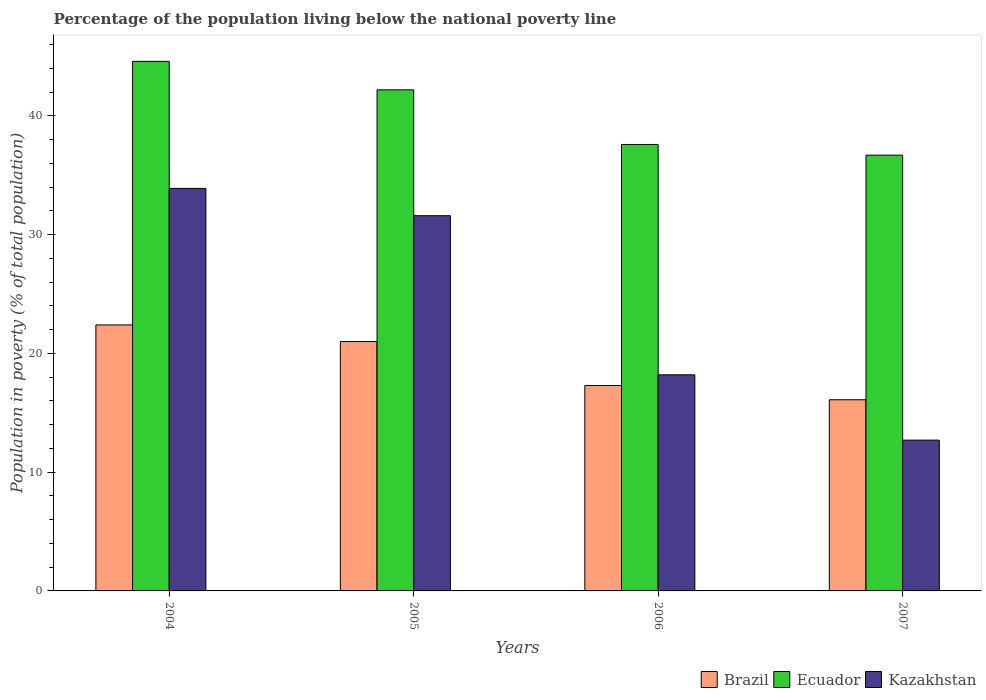How many bars are there on the 1st tick from the left?
Your response must be concise. 3. What is the label of the 4th group of bars from the left?
Give a very brief answer. 2007. What is the percentage of the population living below the national poverty line in Ecuador in 2007?
Ensure brevity in your answer.  36.7. Across all years, what is the maximum percentage of the population living below the national poverty line in Brazil?
Offer a terse response. 22.4. In which year was the percentage of the population living below the national poverty line in Brazil maximum?
Make the answer very short. 2004. What is the total percentage of the population living below the national poverty line in Kazakhstan in the graph?
Provide a succinct answer. 96.4. What is the difference between the percentage of the population living below the national poverty line in Kazakhstan in 2005 and that in 2007?
Your answer should be very brief. 18.9. What is the difference between the percentage of the population living below the national poverty line in Ecuador in 2007 and the percentage of the population living below the national poverty line in Kazakhstan in 2005?
Keep it short and to the point. 5.1. What is the average percentage of the population living below the national poverty line in Kazakhstan per year?
Offer a very short reply. 24.1. In the year 2007, what is the difference between the percentage of the population living below the national poverty line in Ecuador and percentage of the population living below the national poverty line in Kazakhstan?
Offer a terse response. 24. What is the ratio of the percentage of the population living below the national poverty line in Kazakhstan in 2004 to that in 2006?
Provide a short and direct response. 1.86. Is the difference between the percentage of the population living below the national poverty line in Ecuador in 2004 and 2006 greater than the difference between the percentage of the population living below the national poverty line in Kazakhstan in 2004 and 2006?
Make the answer very short. No. What is the difference between the highest and the second highest percentage of the population living below the national poverty line in Kazakhstan?
Your response must be concise. 2.3. What is the difference between the highest and the lowest percentage of the population living below the national poverty line in Kazakhstan?
Your answer should be compact. 21.2. In how many years, is the percentage of the population living below the national poverty line in Kazakhstan greater than the average percentage of the population living below the national poverty line in Kazakhstan taken over all years?
Provide a succinct answer. 2. What does the 1st bar from the left in 2007 represents?
Offer a terse response. Brazil. What does the 1st bar from the right in 2004 represents?
Your response must be concise. Kazakhstan. How many years are there in the graph?
Your answer should be compact. 4. What is the difference between two consecutive major ticks on the Y-axis?
Provide a succinct answer. 10. Are the values on the major ticks of Y-axis written in scientific E-notation?
Your answer should be compact. No. Does the graph contain any zero values?
Offer a terse response. No. What is the title of the graph?
Your answer should be compact. Percentage of the population living below the national poverty line. What is the label or title of the X-axis?
Offer a very short reply. Years. What is the label or title of the Y-axis?
Give a very brief answer. Population in poverty (% of total population). What is the Population in poverty (% of total population) of Brazil in 2004?
Provide a short and direct response. 22.4. What is the Population in poverty (% of total population) in Ecuador in 2004?
Give a very brief answer. 44.6. What is the Population in poverty (% of total population) in Kazakhstan in 2004?
Your answer should be very brief. 33.9. What is the Population in poverty (% of total population) in Brazil in 2005?
Make the answer very short. 21. What is the Population in poverty (% of total population) of Ecuador in 2005?
Your answer should be compact. 42.2. What is the Population in poverty (% of total population) of Kazakhstan in 2005?
Provide a short and direct response. 31.6. What is the Population in poverty (% of total population) in Ecuador in 2006?
Offer a terse response. 37.6. What is the Population in poverty (% of total population) in Ecuador in 2007?
Offer a very short reply. 36.7. Across all years, what is the maximum Population in poverty (% of total population) in Brazil?
Offer a terse response. 22.4. Across all years, what is the maximum Population in poverty (% of total population) of Ecuador?
Provide a succinct answer. 44.6. Across all years, what is the maximum Population in poverty (% of total population) in Kazakhstan?
Ensure brevity in your answer.  33.9. Across all years, what is the minimum Population in poverty (% of total population) of Ecuador?
Offer a very short reply. 36.7. Across all years, what is the minimum Population in poverty (% of total population) of Kazakhstan?
Your response must be concise. 12.7. What is the total Population in poverty (% of total population) in Brazil in the graph?
Make the answer very short. 76.8. What is the total Population in poverty (% of total population) in Ecuador in the graph?
Your answer should be compact. 161.1. What is the total Population in poverty (% of total population) of Kazakhstan in the graph?
Ensure brevity in your answer.  96.4. What is the difference between the Population in poverty (% of total population) of Kazakhstan in 2004 and that in 2005?
Your response must be concise. 2.3. What is the difference between the Population in poverty (% of total population) in Brazil in 2004 and that in 2007?
Make the answer very short. 6.3. What is the difference between the Population in poverty (% of total population) of Kazakhstan in 2004 and that in 2007?
Provide a short and direct response. 21.2. What is the difference between the Population in poverty (% of total population) in Ecuador in 2005 and that in 2006?
Make the answer very short. 4.6. What is the difference between the Population in poverty (% of total population) in Kazakhstan in 2005 and that in 2006?
Your answer should be very brief. 13.4. What is the difference between the Population in poverty (% of total population) of Ecuador in 2005 and that in 2007?
Provide a succinct answer. 5.5. What is the difference between the Population in poverty (% of total population) of Kazakhstan in 2005 and that in 2007?
Provide a succinct answer. 18.9. What is the difference between the Population in poverty (% of total population) in Brazil in 2006 and that in 2007?
Your answer should be compact. 1.2. What is the difference between the Population in poverty (% of total population) of Kazakhstan in 2006 and that in 2007?
Your response must be concise. 5.5. What is the difference between the Population in poverty (% of total population) of Brazil in 2004 and the Population in poverty (% of total population) of Ecuador in 2005?
Offer a very short reply. -19.8. What is the difference between the Population in poverty (% of total population) in Brazil in 2004 and the Population in poverty (% of total population) in Kazakhstan in 2005?
Make the answer very short. -9.2. What is the difference between the Population in poverty (% of total population) in Ecuador in 2004 and the Population in poverty (% of total population) in Kazakhstan in 2005?
Provide a succinct answer. 13. What is the difference between the Population in poverty (% of total population) in Brazil in 2004 and the Population in poverty (% of total population) in Ecuador in 2006?
Make the answer very short. -15.2. What is the difference between the Population in poverty (% of total population) in Ecuador in 2004 and the Population in poverty (% of total population) in Kazakhstan in 2006?
Your response must be concise. 26.4. What is the difference between the Population in poverty (% of total population) of Brazil in 2004 and the Population in poverty (% of total population) of Ecuador in 2007?
Your answer should be very brief. -14.3. What is the difference between the Population in poverty (% of total population) of Brazil in 2004 and the Population in poverty (% of total population) of Kazakhstan in 2007?
Provide a short and direct response. 9.7. What is the difference between the Population in poverty (% of total population) of Ecuador in 2004 and the Population in poverty (% of total population) of Kazakhstan in 2007?
Your answer should be very brief. 31.9. What is the difference between the Population in poverty (% of total population) of Brazil in 2005 and the Population in poverty (% of total population) of Ecuador in 2006?
Give a very brief answer. -16.6. What is the difference between the Population in poverty (% of total population) in Brazil in 2005 and the Population in poverty (% of total population) in Ecuador in 2007?
Keep it short and to the point. -15.7. What is the difference between the Population in poverty (% of total population) of Brazil in 2005 and the Population in poverty (% of total population) of Kazakhstan in 2007?
Your response must be concise. 8.3. What is the difference between the Population in poverty (% of total population) in Ecuador in 2005 and the Population in poverty (% of total population) in Kazakhstan in 2007?
Offer a very short reply. 29.5. What is the difference between the Population in poverty (% of total population) in Brazil in 2006 and the Population in poverty (% of total population) in Ecuador in 2007?
Your answer should be compact. -19.4. What is the difference between the Population in poverty (% of total population) in Brazil in 2006 and the Population in poverty (% of total population) in Kazakhstan in 2007?
Your response must be concise. 4.6. What is the difference between the Population in poverty (% of total population) of Ecuador in 2006 and the Population in poverty (% of total population) of Kazakhstan in 2007?
Make the answer very short. 24.9. What is the average Population in poverty (% of total population) of Ecuador per year?
Your answer should be compact. 40.27. What is the average Population in poverty (% of total population) in Kazakhstan per year?
Give a very brief answer. 24.1. In the year 2004, what is the difference between the Population in poverty (% of total population) in Brazil and Population in poverty (% of total population) in Ecuador?
Keep it short and to the point. -22.2. In the year 2004, what is the difference between the Population in poverty (% of total population) in Brazil and Population in poverty (% of total population) in Kazakhstan?
Offer a terse response. -11.5. In the year 2005, what is the difference between the Population in poverty (% of total population) in Brazil and Population in poverty (% of total population) in Ecuador?
Offer a very short reply. -21.2. In the year 2005, what is the difference between the Population in poverty (% of total population) of Brazil and Population in poverty (% of total population) of Kazakhstan?
Ensure brevity in your answer.  -10.6. In the year 2006, what is the difference between the Population in poverty (% of total population) in Brazil and Population in poverty (% of total population) in Ecuador?
Your response must be concise. -20.3. In the year 2006, what is the difference between the Population in poverty (% of total population) of Ecuador and Population in poverty (% of total population) of Kazakhstan?
Offer a terse response. 19.4. In the year 2007, what is the difference between the Population in poverty (% of total population) of Brazil and Population in poverty (% of total population) of Ecuador?
Provide a succinct answer. -20.6. What is the ratio of the Population in poverty (% of total population) in Brazil in 2004 to that in 2005?
Provide a succinct answer. 1.07. What is the ratio of the Population in poverty (% of total population) of Ecuador in 2004 to that in 2005?
Ensure brevity in your answer.  1.06. What is the ratio of the Population in poverty (% of total population) in Kazakhstan in 2004 to that in 2005?
Provide a short and direct response. 1.07. What is the ratio of the Population in poverty (% of total population) in Brazil in 2004 to that in 2006?
Give a very brief answer. 1.29. What is the ratio of the Population in poverty (% of total population) in Ecuador in 2004 to that in 2006?
Your answer should be compact. 1.19. What is the ratio of the Population in poverty (% of total population) of Kazakhstan in 2004 to that in 2006?
Offer a very short reply. 1.86. What is the ratio of the Population in poverty (% of total population) of Brazil in 2004 to that in 2007?
Your response must be concise. 1.39. What is the ratio of the Population in poverty (% of total population) in Ecuador in 2004 to that in 2007?
Provide a short and direct response. 1.22. What is the ratio of the Population in poverty (% of total population) in Kazakhstan in 2004 to that in 2007?
Your answer should be very brief. 2.67. What is the ratio of the Population in poverty (% of total population) of Brazil in 2005 to that in 2006?
Your response must be concise. 1.21. What is the ratio of the Population in poverty (% of total population) in Ecuador in 2005 to that in 2006?
Provide a succinct answer. 1.12. What is the ratio of the Population in poverty (% of total population) of Kazakhstan in 2005 to that in 2006?
Provide a short and direct response. 1.74. What is the ratio of the Population in poverty (% of total population) in Brazil in 2005 to that in 2007?
Offer a terse response. 1.3. What is the ratio of the Population in poverty (% of total population) of Ecuador in 2005 to that in 2007?
Provide a short and direct response. 1.15. What is the ratio of the Population in poverty (% of total population) in Kazakhstan in 2005 to that in 2007?
Offer a very short reply. 2.49. What is the ratio of the Population in poverty (% of total population) in Brazil in 2006 to that in 2007?
Provide a succinct answer. 1.07. What is the ratio of the Population in poverty (% of total population) in Ecuador in 2006 to that in 2007?
Keep it short and to the point. 1.02. What is the ratio of the Population in poverty (% of total population) in Kazakhstan in 2006 to that in 2007?
Your answer should be compact. 1.43. What is the difference between the highest and the second highest Population in poverty (% of total population) in Ecuador?
Keep it short and to the point. 2.4. What is the difference between the highest and the lowest Population in poverty (% of total population) in Kazakhstan?
Your response must be concise. 21.2. 